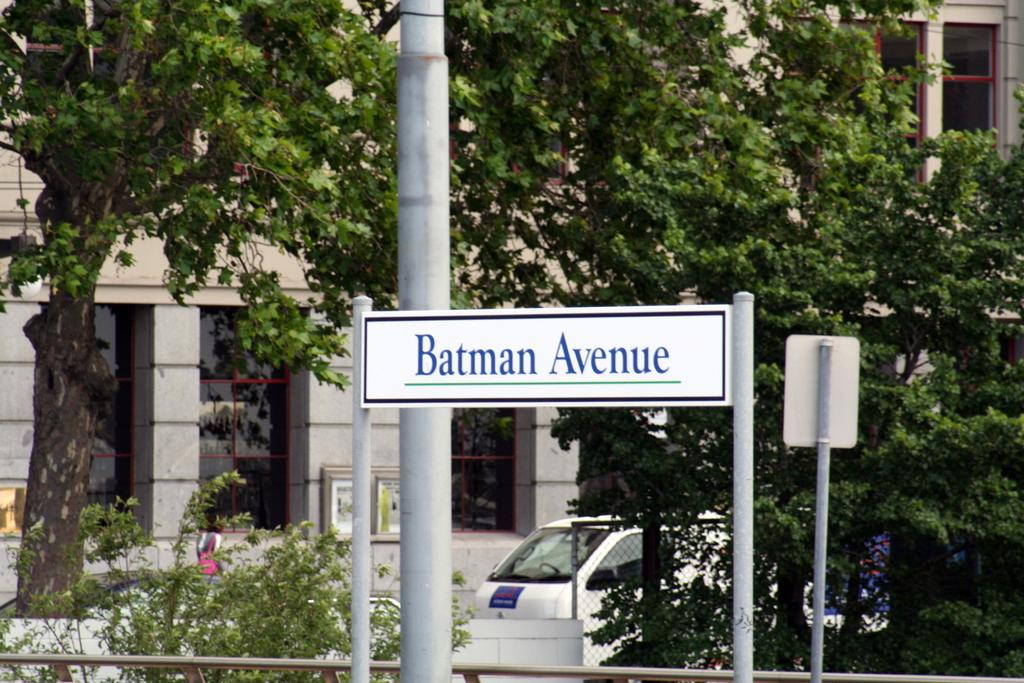What is the main structure in the image? There are boards on poles in the image. Can you describe the arrangement of the boards and poles? There is a pole behind the board. What type of natural elements can be seen in the image? There are plants and trees in the image. What can be seen in the background of the image? There is a fence, a person, a car, a building, and windows visible in the background of the image. How far away is the volcano from the boards on poles in the image? There is no volcano present in the image, so it is not possible to determine the distance between a volcano and the boards on poles. 